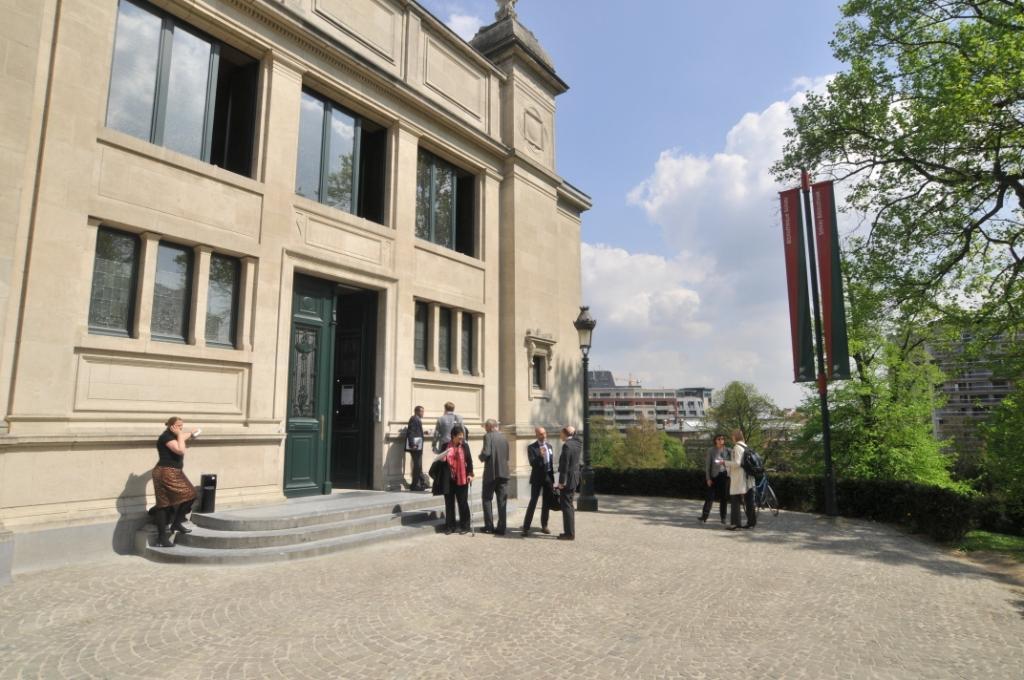Describe this image in one or two sentences. In this picture we can see some people standing, bicycle on the ground and a woman on steps, poles, banners, light, trees, buildings with windows and some objects and in the background we can see the sky with clouds. 